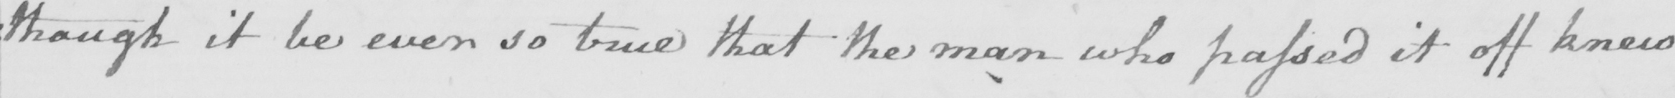Please transcribe the handwritten text in this image. : though it be ever so true that the man who passed it off knew 